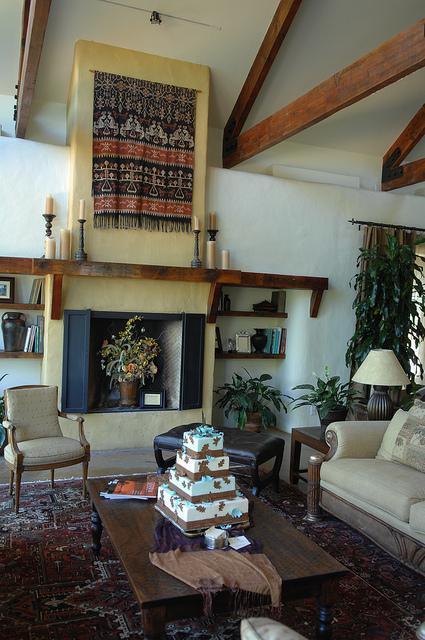How many layers are on the cake?
Give a very brief answer. 4. How many candles are on the mantle?
Give a very brief answer. 8. How many potted plants are visible?
Give a very brief answer. 3. 